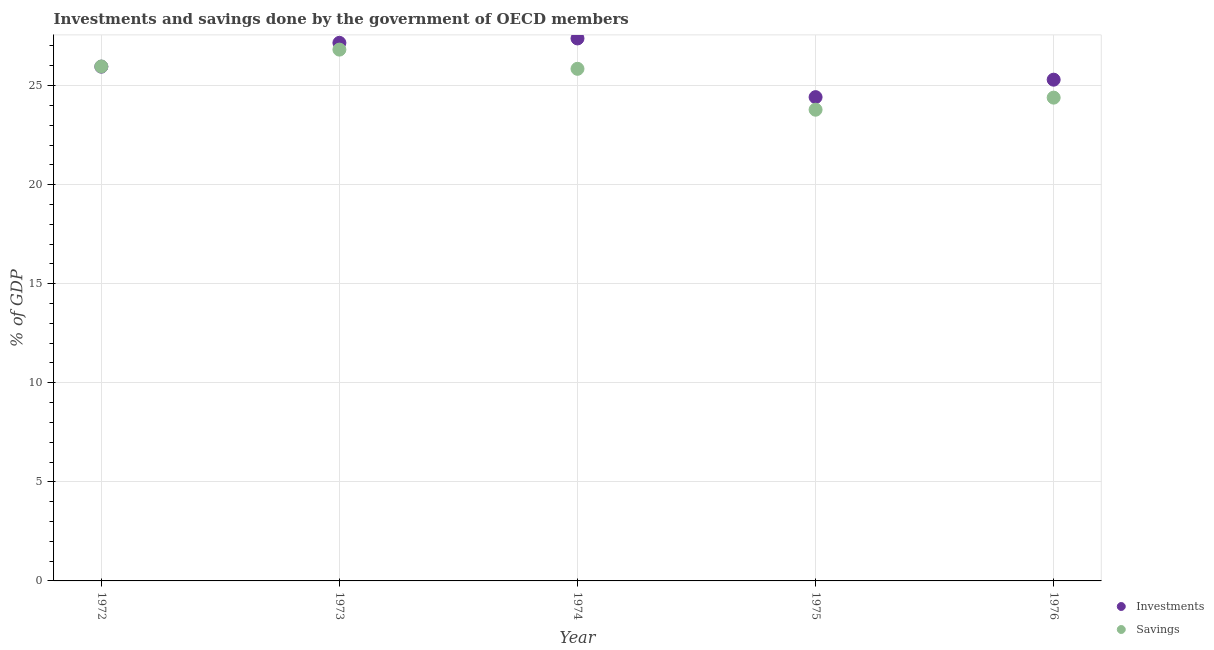Is the number of dotlines equal to the number of legend labels?
Provide a short and direct response. Yes. What is the savings of government in 1973?
Your answer should be compact. 26.82. Across all years, what is the maximum investments of government?
Offer a terse response. 27.38. Across all years, what is the minimum investments of government?
Provide a succinct answer. 24.42. In which year was the investments of government maximum?
Your response must be concise. 1974. In which year was the savings of government minimum?
Offer a terse response. 1975. What is the total investments of government in the graph?
Keep it short and to the point. 130.21. What is the difference between the savings of government in 1972 and that in 1976?
Ensure brevity in your answer.  1.57. What is the difference between the savings of government in 1975 and the investments of government in 1972?
Your response must be concise. -2.17. What is the average investments of government per year?
Offer a very short reply. 26.04. In the year 1972, what is the difference between the savings of government and investments of government?
Make the answer very short. 0.01. What is the ratio of the savings of government in 1972 to that in 1975?
Your answer should be very brief. 1.09. Is the investments of government in 1972 less than that in 1973?
Offer a very short reply. Yes. What is the difference between the highest and the second highest investments of government?
Provide a short and direct response. 0.22. What is the difference between the highest and the lowest investments of government?
Give a very brief answer. 2.96. In how many years, is the savings of government greater than the average savings of government taken over all years?
Your answer should be compact. 3. Is the sum of the investments of government in 1974 and 1975 greater than the maximum savings of government across all years?
Make the answer very short. Yes. Is the investments of government strictly greater than the savings of government over the years?
Ensure brevity in your answer.  No. What is the difference between two consecutive major ticks on the Y-axis?
Your answer should be compact. 5. How many legend labels are there?
Provide a succinct answer. 2. What is the title of the graph?
Your response must be concise. Investments and savings done by the government of OECD members. What is the label or title of the Y-axis?
Your answer should be very brief. % of GDP. What is the % of GDP in Investments in 1972?
Keep it short and to the point. 25.96. What is the % of GDP of Savings in 1972?
Provide a short and direct response. 25.97. What is the % of GDP in Investments in 1973?
Ensure brevity in your answer.  27.16. What is the % of GDP in Savings in 1973?
Make the answer very short. 26.82. What is the % of GDP in Investments in 1974?
Give a very brief answer. 27.38. What is the % of GDP of Savings in 1974?
Keep it short and to the point. 25.85. What is the % of GDP of Investments in 1975?
Give a very brief answer. 24.42. What is the % of GDP in Savings in 1975?
Your answer should be compact. 23.78. What is the % of GDP in Investments in 1976?
Ensure brevity in your answer.  25.3. What is the % of GDP in Savings in 1976?
Give a very brief answer. 24.39. Across all years, what is the maximum % of GDP in Investments?
Your answer should be compact. 27.38. Across all years, what is the maximum % of GDP of Savings?
Offer a very short reply. 26.82. Across all years, what is the minimum % of GDP in Investments?
Offer a terse response. 24.42. Across all years, what is the minimum % of GDP of Savings?
Give a very brief answer. 23.78. What is the total % of GDP in Investments in the graph?
Your response must be concise. 130.21. What is the total % of GDP in Savings in the graph?
Provide a short and direct response. 126.8. What is the difference between the % of GDP in Investments in 1972 and that in 1973?
Make the answer very short. -1.2. What is the difference between the % of GDP in Savings in 1972 and that in 1973?
Make the answer very short. -0.85. What is the difference between the % of GDP in Investments in 1972 and that in 1974?
Your answer should be very brief. -1.42. What is the difference between the % of GDP in Savings in 1972 and that in 1974?
Your response must be concise. 0.12. What is the difference between the % of GDP of Investments in 1972 and that in 1975?
Offer a terse response. 1.54. What is the difference between the % of GDP of Savings in 1972 and that in 1975?
Give a very brief answer. 2.18. What is the difference between the % of GDP in Investments in 1972 and that in 1976?
Provide a short and direct response. 0.66. What is the difference between the % of GDP of Savings in 1972 and that in 1976?
Your response must be concise. 1.57. What is the difference between the % of GDP in Investments in 1973 and that in 1974?
Make the answer very short. -0.22. What is the difference between the % of GDP of Savings in 1973 and that in 1974?
Offer a terse response. 0.97. What is the difference between the % of GDP in Investments in 1973 and that in 1975?
Make the answer very short. 2.74. What is the difference between the % of GDP of Savings in 1973 and that in 1975?
Your answer should be very brief. 3.03. What is the difference between the % of GDP in Investments in 1973 and that in 1976?
Offer a very short reply. 1.86. What is the difference between the % of GDP of Savings in 1973 and that in 1976?
Your response must be concise. 2.42. What is the difference between the % of GDP in Investments in 1974 and that in 1975?
Offer a very short reply. 2.96. What is the difference between the % of GDP of Savings in 1974 and that in 1975?
Give a very brief answer. 2.06. What is the difference between the % of GDP of Investments in 1974 and that in 1976?
Your answer should be compact. 2.08. What is the difference between the % of GDP of Savings in 1974 and that in 1976?
Ensure brevity in your answer.  1.45. What is the difference between the % of GDP in Investments in 1975 and that in 1976?
Provide a short and direct response. -0.88. What is the difference between the % of GDP in Savings in 1975 and that in 1976?
Provide a succinct answer. -0.61. What is the difference between the % of GDP of Investments in 1972 and the % of GDP of Savings in 1973?
Your answer should be compact. -0.86. What is the difference between the % of GDP of Investments in 1972 and the % of GDP of Savings in 1974?
Your answer should be very brief. 0.11. What is the difference between the % of GDP of Investments in 1972 and the % of GDP of Savings in 1975?
Offer a terse response. 2.17. What is the difference between the % of GDP in Investments in 1972 and the % of GDP in Savings in 1976?
Provide a short and direct response. 1.56. What is the difference between the % of GDP of Investments in 1973 and the % of GDP of Savings in 1974?
Provide a succinct answer. 1.31. What is the difference between the % of GDP of Investments in 1973 and the % of GDP of Savings in 1975?
Your response must be concise. 3.38. What is the difference between the % of GDP of Investments in 1973 and the % of GDP of Savings in 1976?
Give a very brief answer. 2.77. What is the difference between the % of GDP of Investments in 1974 and the % of GDP of Savings in 1975?
Give a very brief answer. 3.6. What is the difference between the % of GDP of Investments in 1974 and the % of GDP of Savings in 1976?
Your answer should be compact. 2.99. What is the difference between the % of GDP of Investments in 1975 and the % of GDP of Savings in 1976?
Offer a very short reply. 0.03. What is the average % of GDP of Investments per year?
Your answer should be very brief. 26.04. What is the average % of GDP of Savings per year?
Your response must be concise. 25.36. In the year 1972, what is the difference between the % of GDP of Investments and % of GDP of Savings?
Provide a short and direct response. -0.01. In the year 1973, what is the difference between the % of GDP in Investments and % of GDP in Savings?
Offer a very short reply. 0.34. In the year 1974, what is the difference between the % of GDP in Investments and % of GDP in Savings?
Provide a short and direct response. 1.53. In the year 1975, what is the difference between the % of GDP in Investments and % of GDP in Savings?
Offer a very short reply. 0.63. In the year 1976, what is the difference between the % of GDP of Investments and % of GDP of Savings?
Ensure brevity in your answer.  0.91. What is the ratio of the % of GDP in Investments in 1972 to that in 1973?
Offer a very short reply. 0.96. What is the ratio of the % of GDP in Savings in 1972 to that in 1973?
Make the answer very short. 0.97. What is the ratio of the % of GDP in Investments in 1972 to that in 1974?
Provide a succinct answer. 0.95. What is the ratio of the % of GDP in Savings in 1972 to that in 1974?
Your answer should be compact. 1. What is the ratio of the % of GDP of Investments in 1972 to that in 1975?
Offer a very short reply. 1.06. What is the ratio of the % of GDP in Savings in 1972 to that in 1975?
Ensure brevity in your answer.  1.09. What is the ratio of the % of GDP in Savings in 1972 to that in 1976?
Give a very brief answer. 1.06. What is the ratio of the % of GDP in Savings in 1973 to that in 1974?
Provide a short and direct response. 1.04. What is the ratio of the % of GDP of Investments in 1973 to that in 1975?
Your answer should be very brief. 1.11. What is the ratio of the % of GDP in Savings in 1973 to that in 1975?
Make the answer very short. 1.13. What is the ratio of the % of GDP of Investments in 1973 to that in 1976?
Provide a short and direct response. 1.07. What is the ratio of the % of GDP in Savings in 1973 to that in 1976?
Offer a terse response. 1.1. What is the ratio of the % of GDP of Investments in 1974 to that in 1975?
Give a very brief answer. 1.12. What is the ratio of the % of GDP in Savings in 1974 to that in 1975?
Provide a short and direct response. 1.09. What is the ratio of the % of GDP of Investments in 1974 to that in 1976?
Your answer should be very brief. 1.08. What is the ratio of the % of GDP in Savings in 1974 to that in 1976?
Ensure brevity in your answer.  1.06. What is the ratio of the % of GDP in Investments in 1975 to that in 1976?
Offer a very short reply. 0.97. What is the difference between the highest and the second highest % of GDP in Investments?
Give a very brief answer. 0.22. What is the difference between the highest and the second highest % of GDP of Savings?
Offer a very short reply. 0.85. What is the difference between the highest and the lowest % of GDP of Investments?
Provide a short and direct response. 2.96. What is the difference between the highest and the lowest % of GDP of Savings?
Make the answer very short. 3.03. 